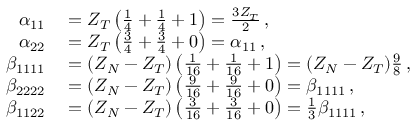Convert formula to latex. <formula><loc_0><loc_0><loc_500><loc_500>\begin{array} { r l } { \alpha _ { 1 1 } } & = Z _ { T } \left ( \frac { 1 } { 4 } + \frac { 1 } { 4 } + 1 \right ) = \frac { 3 Z _ { T } } { 2 } \, , } \\ { \alpha _ { 2 2 } } & = Z _ { T } \left ( \frac { 3 } { 4 } + \frac { 3 } { 4 } + 0 \right ) = \alpha _ { 1 1 } \, , } \\ { \beta _ { 1 1 1 1 } } & = ( Z _ { N } - Z _ { T } ) \left ( \frac { 1 } { 1 6 } + \frac { 1 } { 1 6 } + 1 \right ) = ( Z _ { N } - Z _ { T } ) \frac { 9 } { 8 } \, , } \\ { \beta _ { 2 2 2 2 } } & = ( Z _ { N } - Z _ { T } ) \left ( \frac { 9 } { 1 6 } + \frac { 9 } { 1 6 } + 0 \right ) = \beta _ { 1 1 1 1 } \, , } \\ { \beta _ { 1 1 2 2 } } & = ( Z _ { N } - Z _ { T } ) \left ( \frac { 3 } { 1 6 } + \frac { 3 } { 1 6 } + 0 \right ) = \frac { 1 } { 3 } \beta _ { 1 1 1 1 } \, , } \end{array}</formula> 